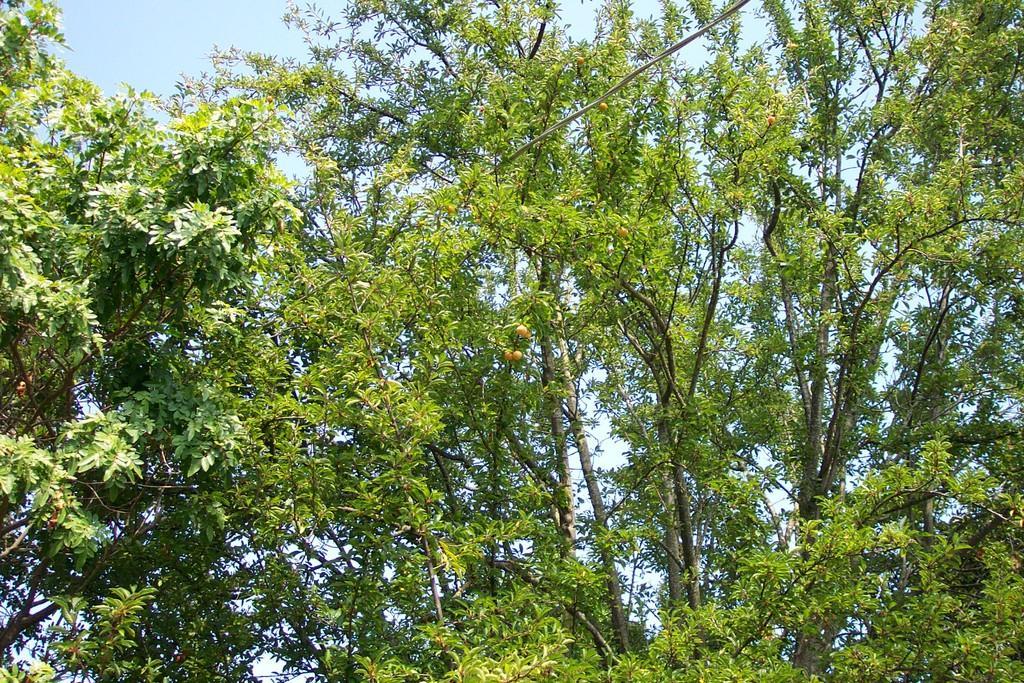In one or two sentences, can you explain what this image depicts? In this image we can see trees, some fruits, a wire and some part of the sky. 